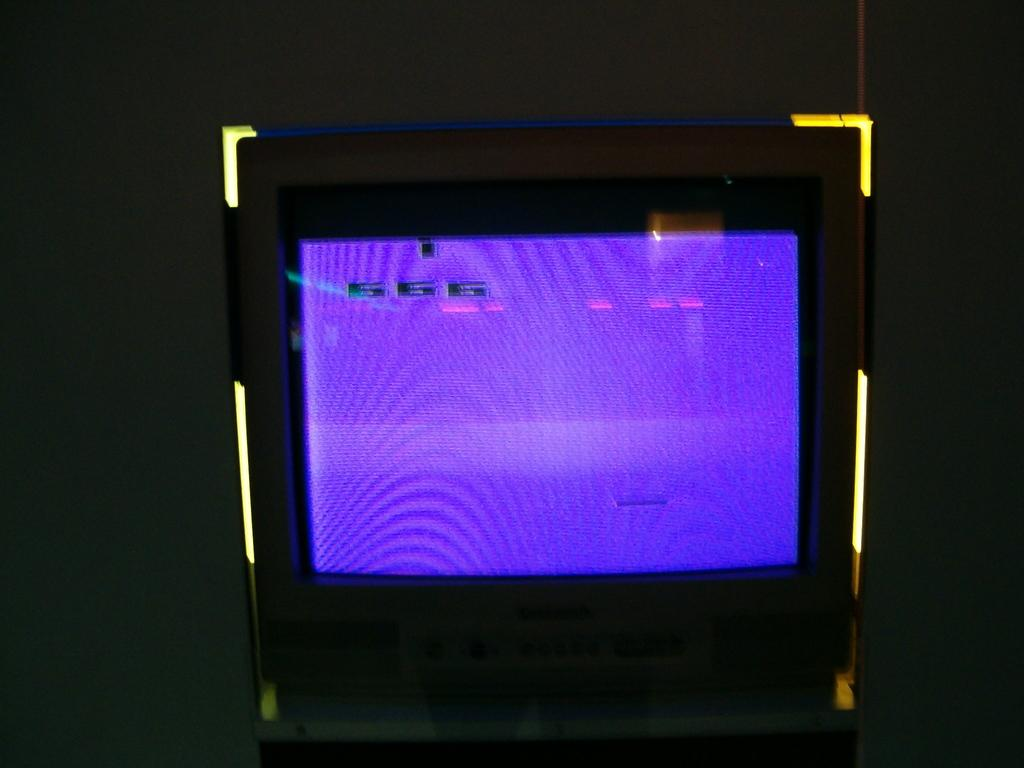<image>
Describe the image concisely. a blue screen with the numbers 566 on it 